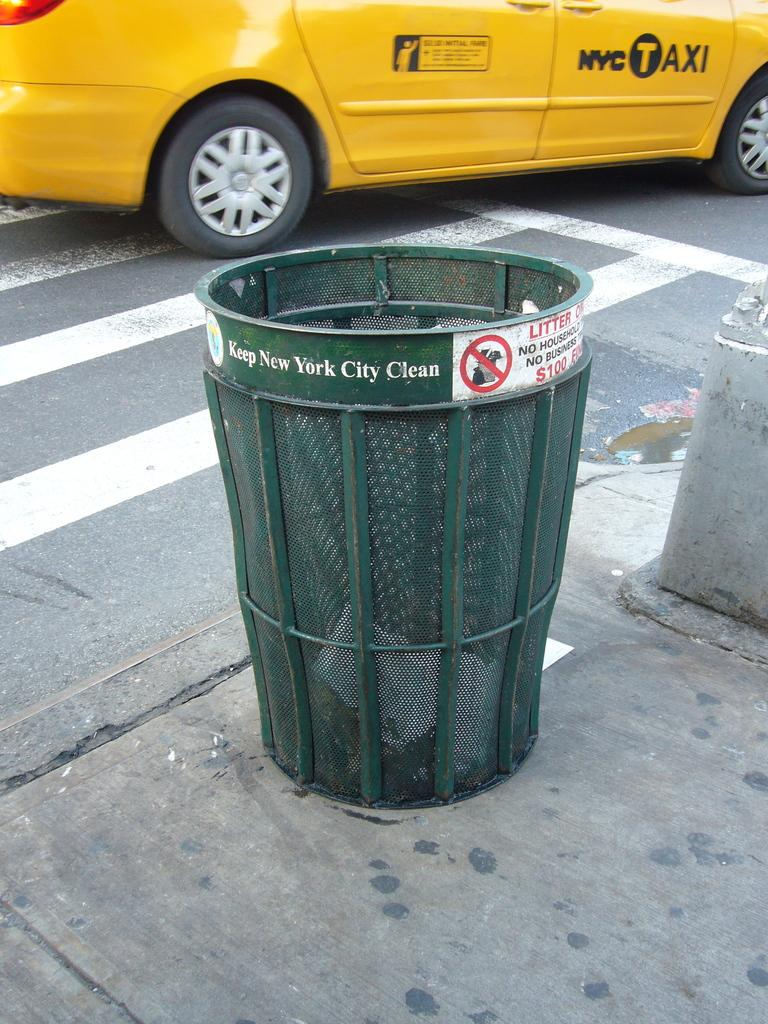<image>
Render a clear and concise summary of the photo. Green Wire mesh trash can with sign that read Keep New York City Clean. 